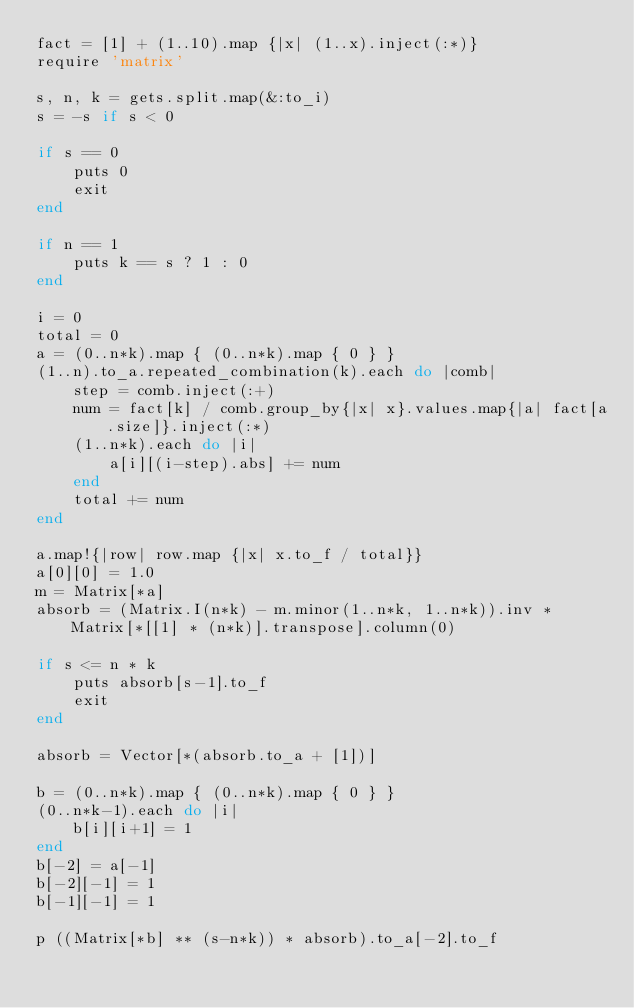<code> <loc_0><loc_0><loc_500><loc_500><_Ruby_>fact = [1] + (1..10).map {|x| (1..x).inject(:*)}
require 'matrix'

s, n, k = gets.split.map(&:to_i)
s = -s if s < 0

if s == 0
	puts 0
	exit
end

if n == 1
	puts k == s ? 1 : 0
end

i = 0
total = 0
a = (0..n*k).map { (0..n*k).map { 0 } }
(1..n).to_a.repeated_combination(k).each do |comb|
	step = comb.inject(:+)
	num = fact[k] / comb.group_by{|x| x}.values.map{|a| fact[a.size]}.inject(:*)
	(1..n*k).each do |i|
		a[i][(i-step).abs] += num
	end
	total += num
end

a.map!{|row| row.map {|x| x.to_f / total}}
a[0][0] = 1.0
m = Matrix[*a]
absorb = (Matrix.I(n*k) - m.minor(1..n*k, 1..n*k)).inv * Matrix[*[[1] * (n*k)].transpose].column(0)

if s <= n * k
	puts absorb[s-1].to_f
	exit
end

absorb = Vector[*(absorb.to_a + [1])]

b = (0..n*k).map { (0..n*k).map { 0 } } 
(0..n*k-1).each do |i|
	b[i][i+1] = 1
end
b[-2] = a[-1]
b[-2][-1] = 1
b[-1][-1] = 1

p ((Matrix[*b] ** (s-n*k)) * absorb).to_a[-2].to_f</code> 